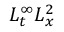<formula> <loc_0><loc_0><loc_500><loc_500>L _ { t } ^ { \infty } L _ { x } ^ { 2 }</formula> 